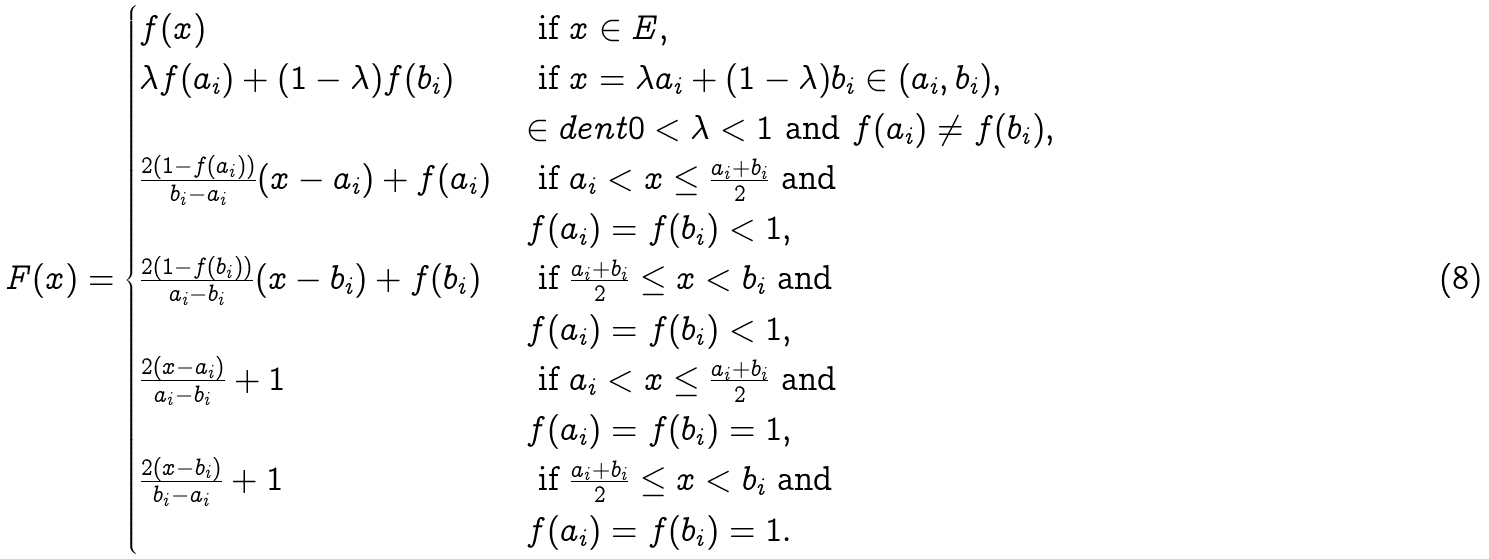<formula> <loc_0><loc_0><loc_500><loc_500>F ( x ) = \begin{cases} f ( x ) & \text { if } x \in E , \\ \lambda f ( a _ { i } ) + ( 1 - \lambda ) f ( b _ { i } ) & \text { if } x = \lambda a _ { i } + ( 1 - \lambda ) b _ { i } \in ( a _ { i } , b _ { i } ) , \\ & \in d e n t 0 < \lambda < 1 \text { and } f ( a _ { i } ) \neq f ( b _ { i } ) , \\ \frac { 2 ( 1 - f ( a _ { i } ) ) } { b _ { i } - a _ { i } } ( x - a _ { i } ) + f ( a _ { i } ) & \text { if  } a _ { i } < x \leq \frac { a _ { i } + b _ { i } } { 2 } \text { and } \\ & f ( a _ { i } ) = f ( b _ { i } ) < 1 , \\ \frac { 2 ( 1 - f ( b _ { i } ) ) } { a _ { i } - b _ { i } } ( x - b _ { i } ) + f ( b _ { i } ) & \text { if  } \frac { a _ { i } + b _ { i } } { 2 } \leq x < b _ { i } \text { and } \\ & f ( a _ { i } ) = f ( b _ { i } ) < 1 , \\ \frac { 2 ( x - a _ { i } ) } { a _ { i } - b _ { i } } + 1 & \text { if  } a _ { i } < x \leq \frac { a _ { i } + b _ { i } } { 2 } \text { and } \\ & f ( a _ { i } ) = f ( b _ { i } ) = 1 , \\ \frac { 2 ( x - b _ { i } ) } { b _ { i } - a _ { i } } + 1 & \text { if  } \frac { a _ { i } + b _ { i } } { 2 } \leq x < b _ { i } \text { and } \\ & f ( a _ { i } ) = f ( b _ { i } ) = 1 . \\ \end{cases}</formula> 